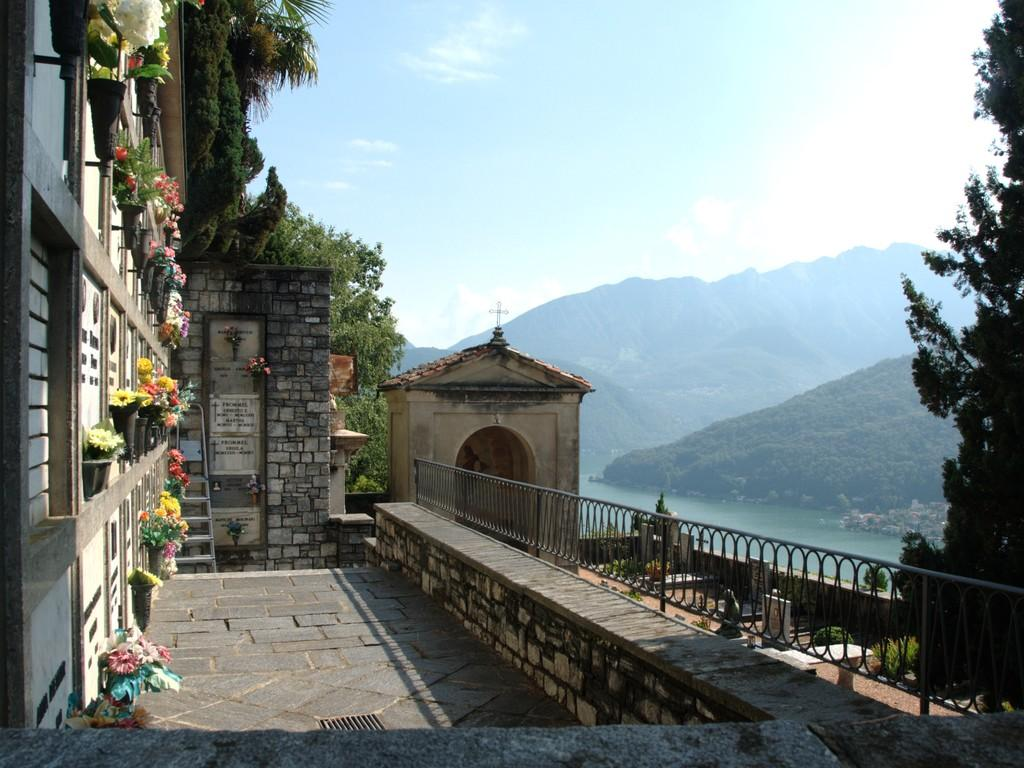What type of structures can be seen in the image? There are walls in the image. What type of plants are present in the image? There are flower plants with pots in the image. What type of architectural feature can be seen in the image? There are railings in the image. What type of natural elements are present in the image? There are trees in the image. What type of objects can be seen in the image? There are objects in the image. What can be seen in the background of the image? The background of the image includes water, hills, trees, and the sky. How many kittens are playing with the cable in the image? There are no kittens or cables present in the image. What type of weather can be inferred from the presence of thunder in the image? There is no thunder present in the image, so it cannot be used to infer the weather. 